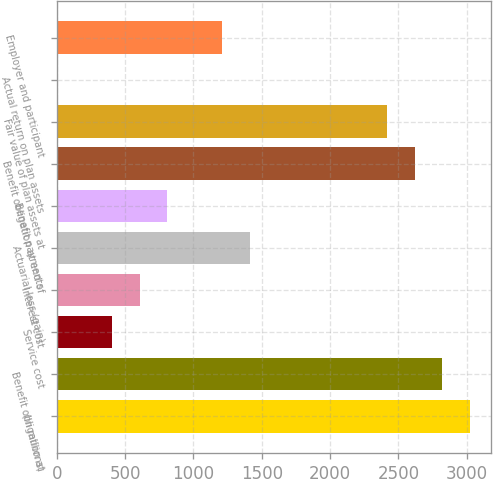<chart> <loc_0><loc_0><loc_500><loc_500><bar_chart><fcel>(In millions)<fcel>Benefit obligation at<fcel>Service cost<fcel>Interest cost<fcel>Actuarial loss (gain)<fcel>Benefit payments<fcel>Benefit obligation at end of<fcel>Fair value of plan assets at<fcel>Actual return on plan assets<fcel>Employer and participant<nl><fcel>3023<fcel>2821.6<fcel>404.8<fcel>606.2<fcel>1411.8<fcel>807.6<fcel>2620.2<fcel>2418.8<fcel>2<fcel>1210.4<nl></chart> 